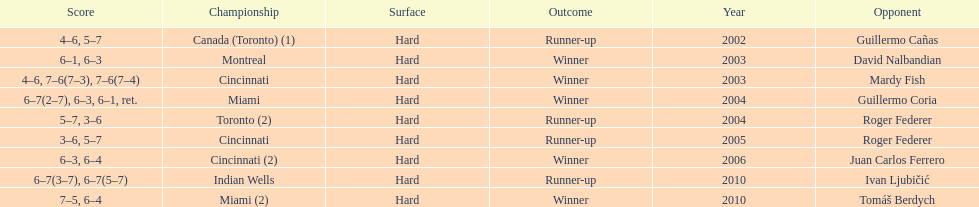How many times were roddick's opponents not from the usa? 8. 